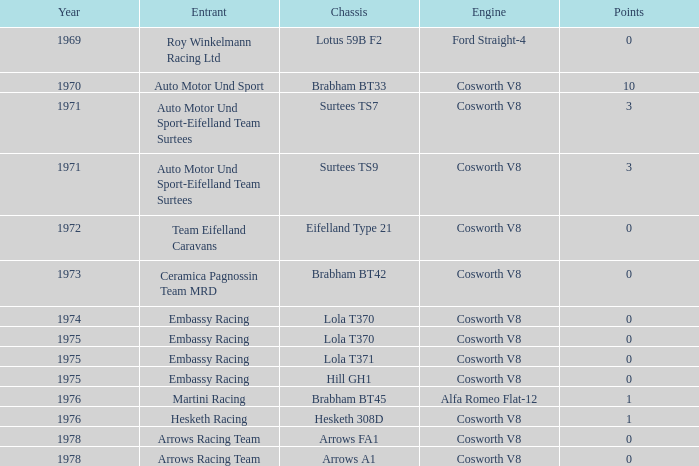What was the combined total of points in 1978 with an arrows fa1 chassis? 0.0. 